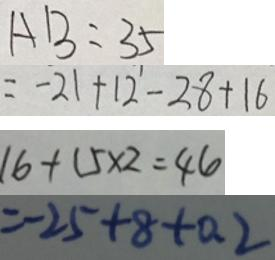Convert formula to latex. <formula><loc_0><loc_0><loc_500><loc_500>A B = 3 5 
 = - 2 1 + 1 2 - 2 8 + 1 6 
 1 6 + 1 5 \times 2 = 4 6 
 = - 2 5 + 8 + 0 . 2</formula> 